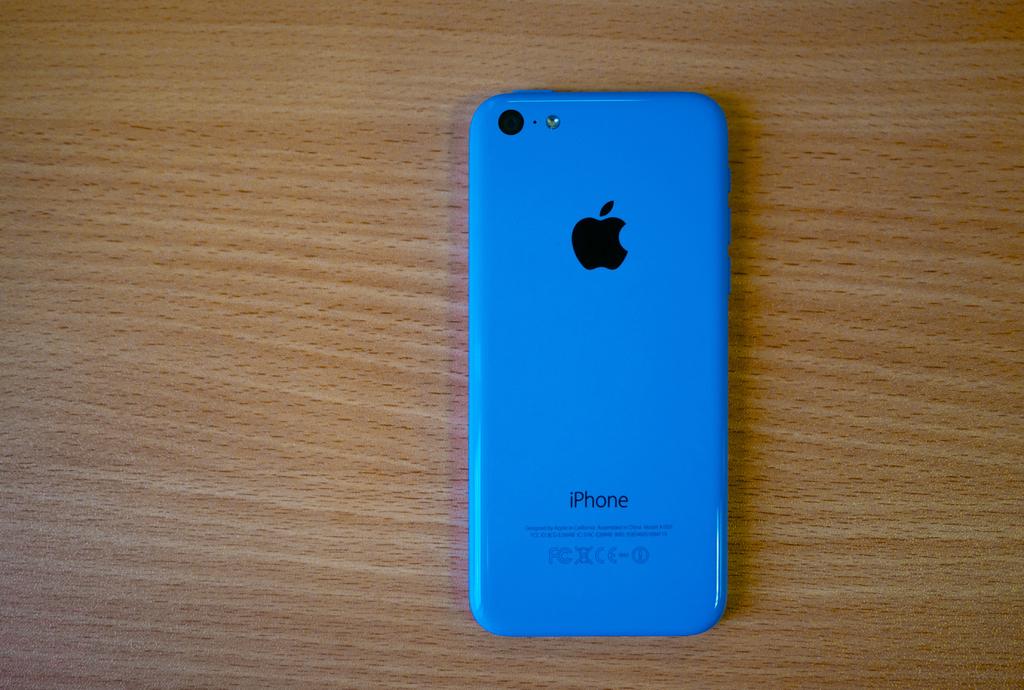What brand of phone is this?
Your response must be concise. Iphone. What color are the logo and words written in?
Keep it short and to the point. Black. 